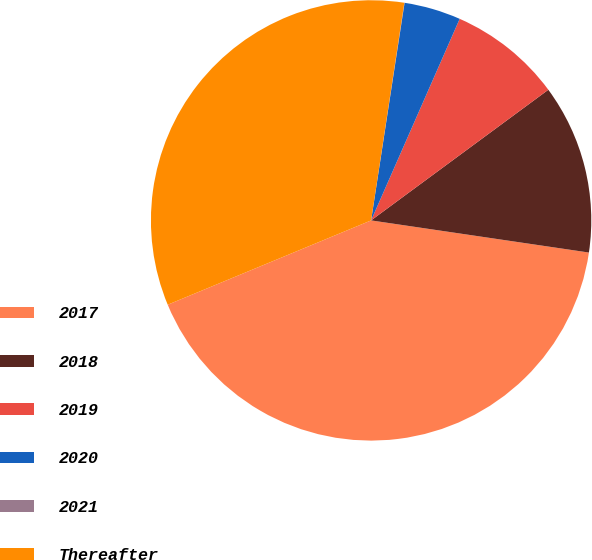<chart> <loc_0><loc_0><loc_500><loc_500><pie_chart><fcel>2017<fcel>2018<fcel>2019<fcel>2020<fcel>2021<fcel>Thereafter<nl><fcel>41.41%<fcel>12.44%<fcel>8.3%<fcel>4.16%<fcel>0.02%<fcel>33.66%<nl></chart> 